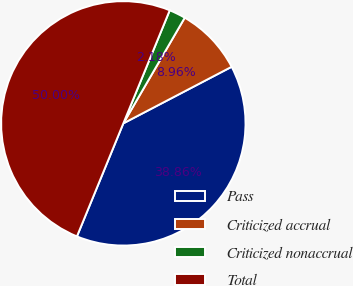Convert chart to OTSL. <chart><loc_0><loc_0><loc_500><loc_500><pie_chart><fcel>Pass<fcel>Criticized accrual<fcel>Criticized nonaccrual<fcel>Total<nl><fcel>38.86%<fcel>8.96%<fcel>2.18%<fcel>50.0%<nl></chart> 